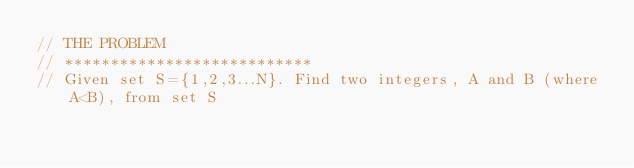<code> <loc_0><loc_0><loc_500><loc_500><_C++_>// THE PROBLEM
// ***************************
// Given set S={1,2,3...N}. Find two integers, A and B (where A<B), from set S </code> 